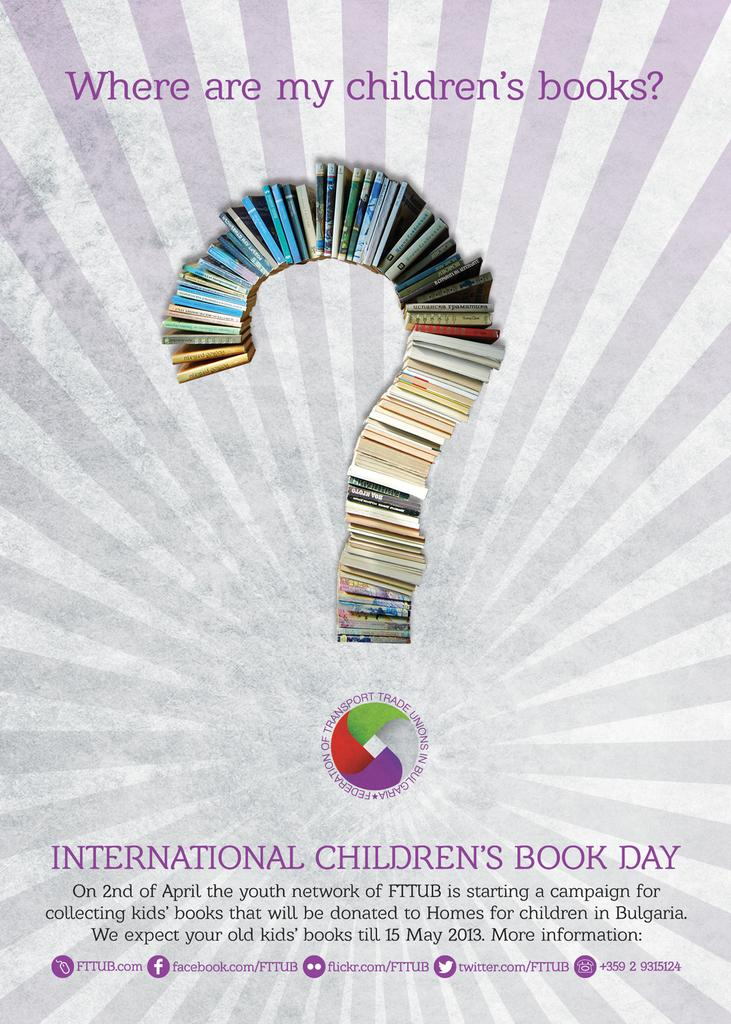<image>
Summarize the visual content of the image. A poster of books in the shape of a question mark for the International Children's Book Day 